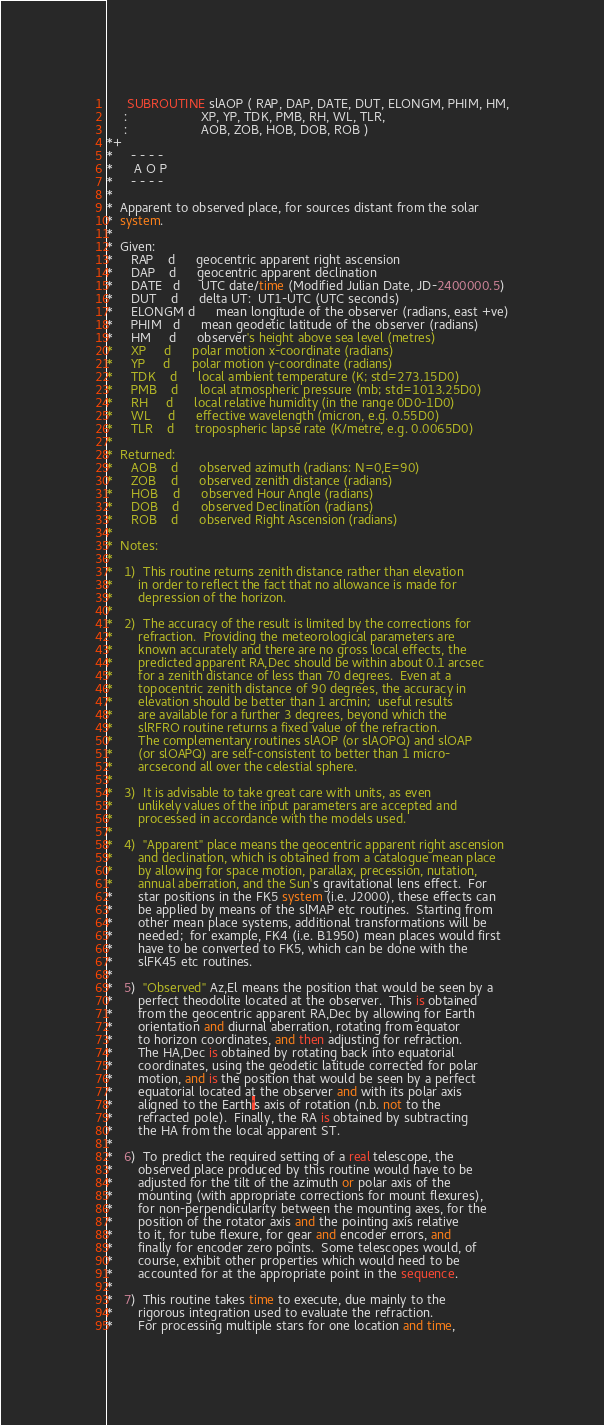<code> <loc_0><loc_0><loc_500><loc_500><_FORTRAN_>      SUBROUTINE slAOP ( RAP, DAP, DATE, DUT, ELONGM, PHIM, HM,
     :                     XP, YP, TDK, PMB, RH, WL, TLR,
     :                     AOB, ZOB, HOB, DOB, ROB )
*+
*     - - - -
*      A O P
*     - - - -
*
*  Apparent to observed place, for sources distant from the solar
*  system.
*
*  Given:
*     RAP    d      geocentric apparent right ascension
*     DAP    d      geocentric apparent declination
*     DATE   d      UTC date/time (Modified Julian Date, JD-2400000.5)
*     DUT    d      delta UT:  UT1-UTC (UTC seconds)
*     ELONGM d      mean longitude of the observer (radians, east +ve)
*     PHIM   d      mean geodetic latitude of the observer (radians)
*     HM     d      observer's height above sea level (metres)
*     XP     d      polar motion x-coordinate (radians)
*     YP     d      polar motion y-coordinate (radians)
*     TDK    d      local ambient temperature (K; std=273.15D0)
*     PMB    d      local atmospheric pressure (mb; std=1013.25D0)
*     RH     d      local relative humidity (in the range 0D0-1D0)
*     WL     d      effective wavelength (micron, e.g. 0.55D0)
*     TLR    d      tropospheric lapse rate (K/metre, e.g. 0.0065D0)
*
*  Returned:
*     AOB    d      observed azimuth (radians: N=0,E=90)
*     ZOB    d      observed zenith distance (radians)
*     HOB    d      observed Hour Angle (radians)
*     DOB    d      observed Declination (radians)
*     ROB    d      observed Right Ascension (radians)
*
*  Notes:
*
*   1)  This routine returns zenith distance rather than elevation
*       in order to reflect the fact that no allowance is made for
*       depression of the horizon.
*
*   2)  The accuracy of the result is limited by the corrections for
*       refraction.  Providing the meteorological parameters are
*       known accurately and there are no gross local effects, the
*       predicted apparent RA,Dec should be within about 0.1 arcsec
*       for a zenith distance of less than 70 degrees.  Even at a
*       topocentric zenith distance of 90 degrees, the accuracy in
*       elevation should be better than 1 arcmin;  useful results
*       are available for a further 3 degrees, beyond which the
*       slRFRO routine returns a fixed value of the refraction.
*       The complementary routines slAOP (or slAOPQ) and slOAP
*       (or slOAPQ) are self-consistent to better than 1 micro-
*       arcsecond all over the celestial sphere.
*
*   3)  It is advisable to take great care with units, as even
*       unlikely values of the input parameters are accepted and
*       processed in accordance with the models used.
*
*   4)  "Apparent" place means the geocentric apparent right ascension
*       and declination, which is obtained from a catalogue mean place
*       by allowing for space motion, parallax, precession, nutation,
*       annual aberration, and the Sun's gravitational lens effect.  For
*       star positions in the FK5 system (i.e. J2000), these effects can
*       be applied by means of the slMAP etc routines.  Starting from
*       other mean place systems, additional transformations will be
*       needed;  for example, FK4 (i.e. B1950) mean places would first
*       have to be converted to FK5, which can be done with the
*       slFK45 etc routines.
*
*   5)  "Observed" Az,El means the position that would be seen by a
*       perfect theodolite located at the observer.  This is obtained
*       from the geocentric apparent RA,Dec by allowing for Earth
*       orientation and diurnal aberration, rotating from equator
*       to horizon coordinates, and then adjusting for refraction.
*       The HA,Dec is obtained by rotating back into equatorial
*       coordinates, using the geodetic latitude corrected for polar
*       motion, and is the position that would be seen by a perfect
*       equatorial located at the observer and with its polar axis
*       aligned to the Earth's axis of rotation (n.b. not to the
*       refracted pole).  Finally, the RA is obtained by subtracting
*       the HA from the local apparent ST.
*
*   6)  To predict the required setting of a real telescope, the
*       observed place produced by this routine would have to be
*       adjusted for the tilt of the azimuth or polar axis of the
*       mounting (with appropriate corrections for mount flexures),
*       for non-perpendicularity between the mounting axes, for the
*       position of the rotator axis and the pointing axis relative
*       to it, for tube flexure, for gear and encoder errors, and
*       finally for encoder zero points.  Some telescopes would, of
*       course, exhibit other properties which would need to be
*       accounted for at the appropriate point in the sequence.
*
*   7)  This routine takes time to execute, due mainly to the
*       rigorous integration used to evaluate the refraction.
*       For processing multiple stars for one location and time,</code> 